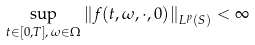Convert formula to latex. <formula><loc_0><loc_0><loc_500><loc_500>\sup _ { t \in [ 0 , T ] , \, \omega \in \Omega } \left \| f ( t , \omega , \cdot , 0 ) \right \| _ { L ^ { p } ( S ) } < \infty</formula> 